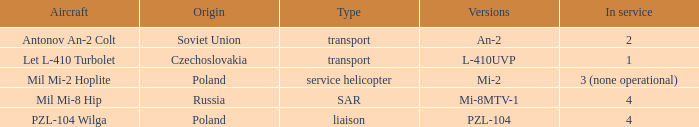Identify the type of aircraft referred to as pzl-104. PZL-104 Wilga. 